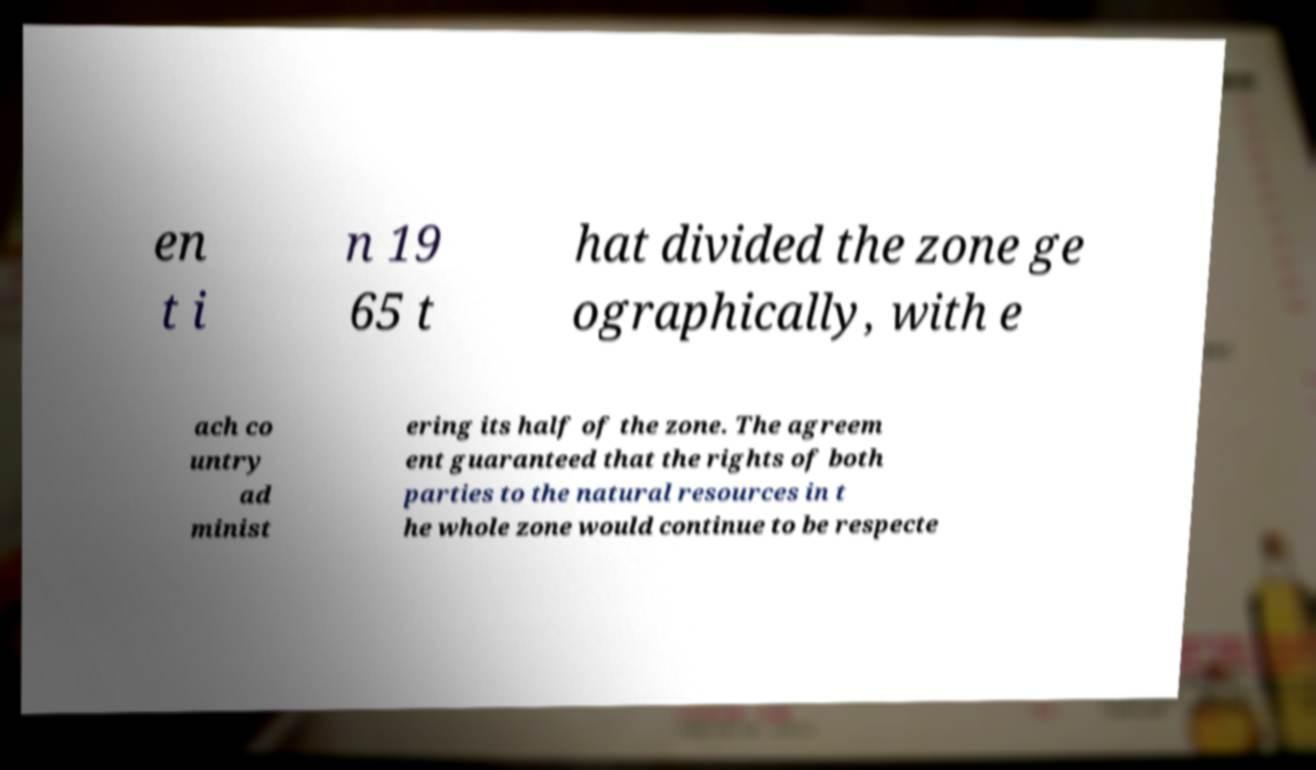I need the written content from this picture converted into text. Can you do that? en t i n 19 65 t hat divided the zone ge ographically, with e ach co untry ad minist ering its half of the zone. The agreem ent guaranteed that the rights of both parties to the natural resources in t he whole zone would continue to be respecte 